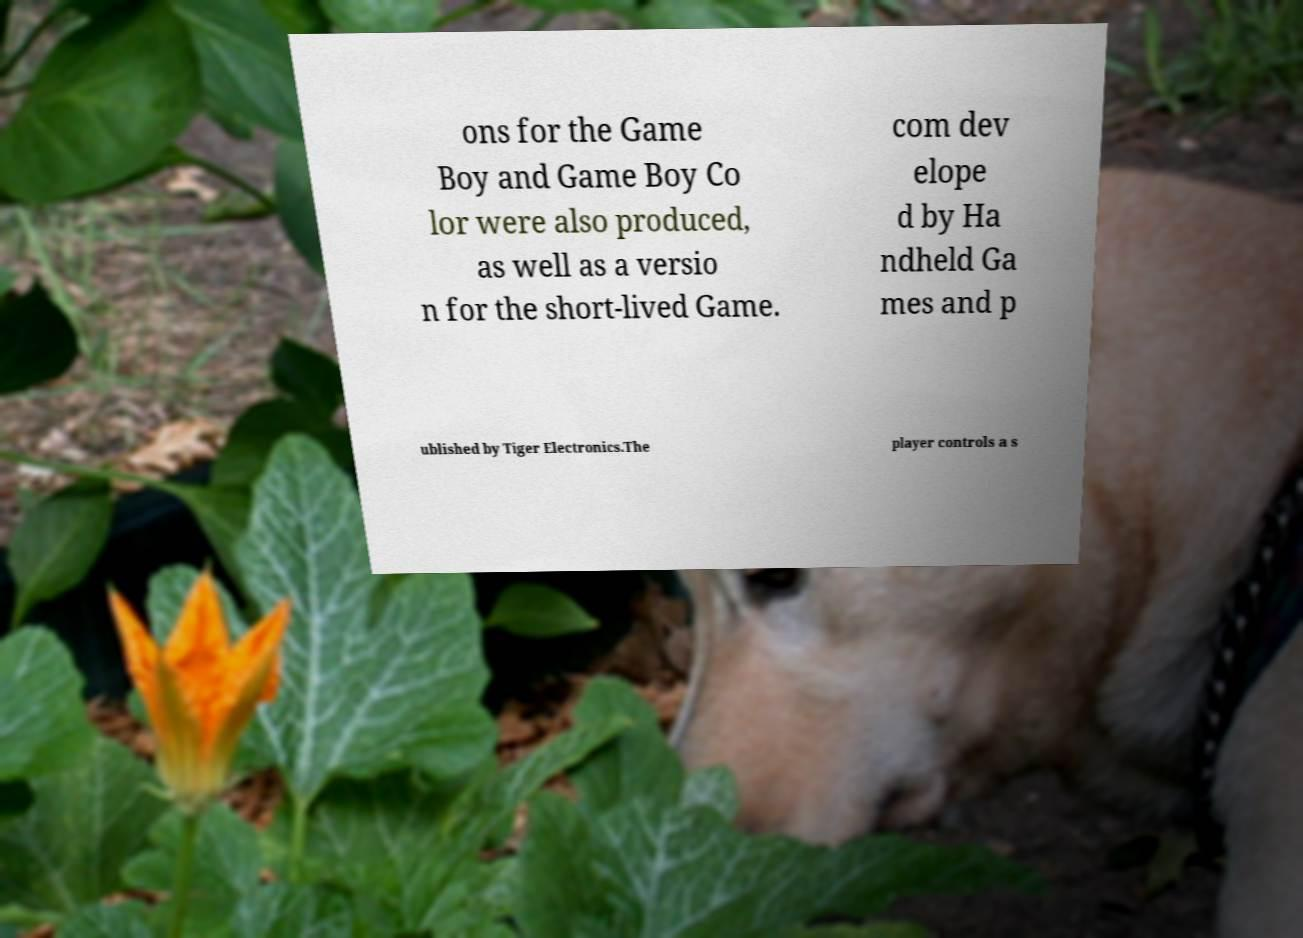For documentation purposes, I need the text within this image transcribed. Could you provide that? ons for the Game Boy and Game Boy Co lor were also produced, as well as a versio n for the short-lived Game. com dev elope d by Ha ndheld Ga mes and p ublished by Tiger Electronics.The player controls a s 